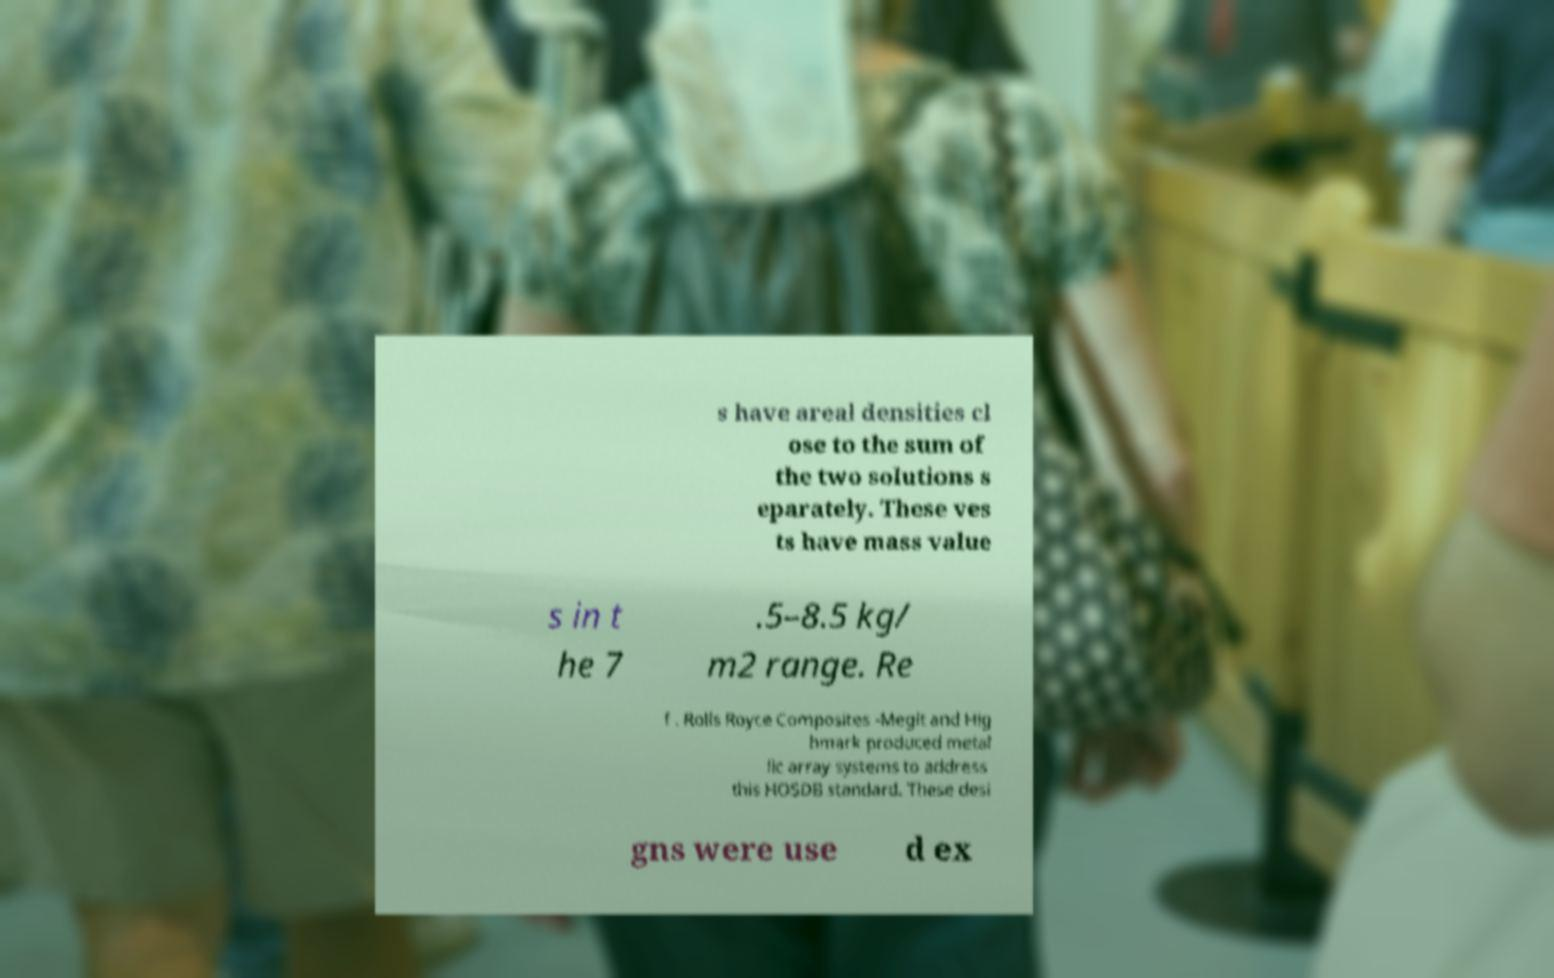Could you extract and type out the text from this image? s have areal densities cl ose to the sum of the two solutions s eparately. These ves ts have mass value s in t he 7 .5–8.5 kg/ m2 range. Re f . Rolls Royce Composites -Megit and Hig hmark produced metal lic array systems to address this HOSDB standard. These desi gns were use d ex 